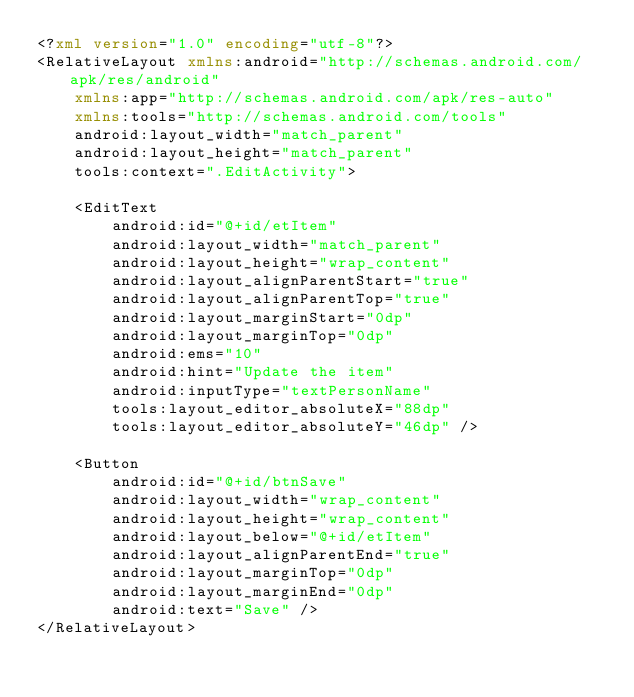Convert code to text. <code><loc_0><loc_0><loc_500><loc_500><_XML_><?xml version="1.0" encoding="utf-8"?>
<RelativeLayout xmlns:android="http://schemas.android.com/apk/res/android"
    xmlns:app="http://schemas.android.com/apk/res-auto"
    xmlns:tools="http://schemas.android.com/tools"
    android:layout_width="match_parent"
    android:layout_height="match_parent"
    tools:context=".EditActivity">

    <EditText
        android:id="@+id/etItem"
        android:layout_width="match_parent"
        android:layout_height="wrap_content"
        android:layout_alignParentStart="true"
        android:layout_alignParentTop="true"
        android:layout_marginStart="0dp"
        android:layout_marginTop="0dp"
        android:ems="10"
        android:hint="Update the item"
        android:inputType="textPersonName"
        tools:layout_editor_absoluteX="88dp"
        tools:layout_editor_absoluteY="46dp" />

    <Button
        android:id="@+id/btnSave"
        android:layout_width="wrap_content"
        android:layout_height="wrap_content"
        android:layout_below="@+id/etItem"
        android:layout_alignParentEnd="true"
        android:layout_marginTop="0dp"
        android:layout_marginEnd="0dp"
        android:text="Save" />
</RelativeLayout></code> 